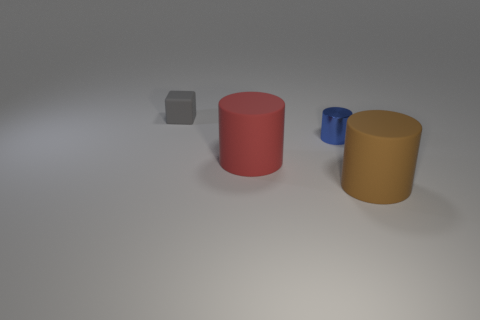Is there anything else that has the same material as the small cylinder?
Give a very brief answer. No. How many big objects are cyan metallic blocks or blue shiny things?
Your response must be concise. 0. Is the number of small gray objects greater than the number of tiny brown objects?
Your response must be concise. Yes. What size is the gray cube that is the same material as the brown cylinder?
Offer a terse response. Small. Do the cylinder to the right of the small cylinder and the metal cylinder behind the large red cylinder have the same size?
Your answer should be compact. No. What number of objects are either cylinders in front of the blue metallic cylinder or small blue metal objects?
Ensure brevity in your answer.  3. Is the number of blue metal cylinders less than the number of blue cubes?
Your answer should be compact. No. There is a large object behind the big rubber thing that is on the right side of the tiny object that is in front of the small gray cube; what is its shape?
Provide a succinct answer. Cylinder. Are any big brown rubber objects visible?
Offer a terse response. Yes. There is a brown matte object; does it have the same size as the thing behind the shiny cylinder?
Your answer should be very brief. No. 